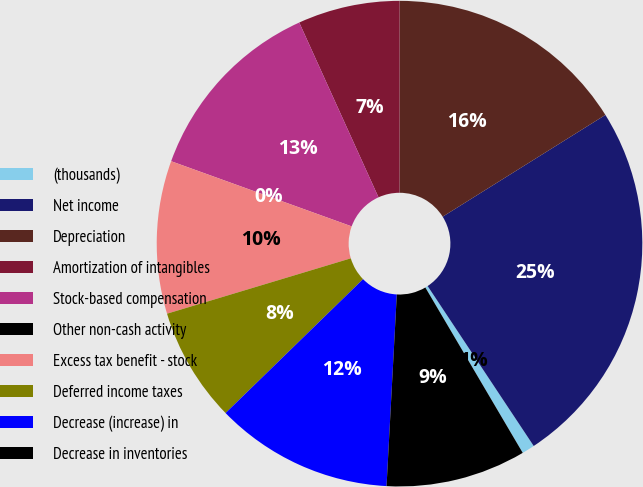Convert chart. <chart><loc_0><loc_0><loc_500><loc_500><pie_chart><fcel>(thousands)<fcel>Net income<fcel>Depreciation<fcel>Amortization of intangibles<fcel>Stock-based compensation<fcel>Other non-cash activity<fcel>Excess tax benefit - stock<fcel>Deferred income taxes<fcel>Decrease (increase) in<fcel>Decrease in inventories<nl><fcel>0.85%<fcel>24.57%<fcel>16.1%<fcel>6.78%<fcel>12.71%<fcel>0.0%<fcel>10.17%<fcel>7.63%<fcel>11.86%<fcel>9.32%<nl></chart> 